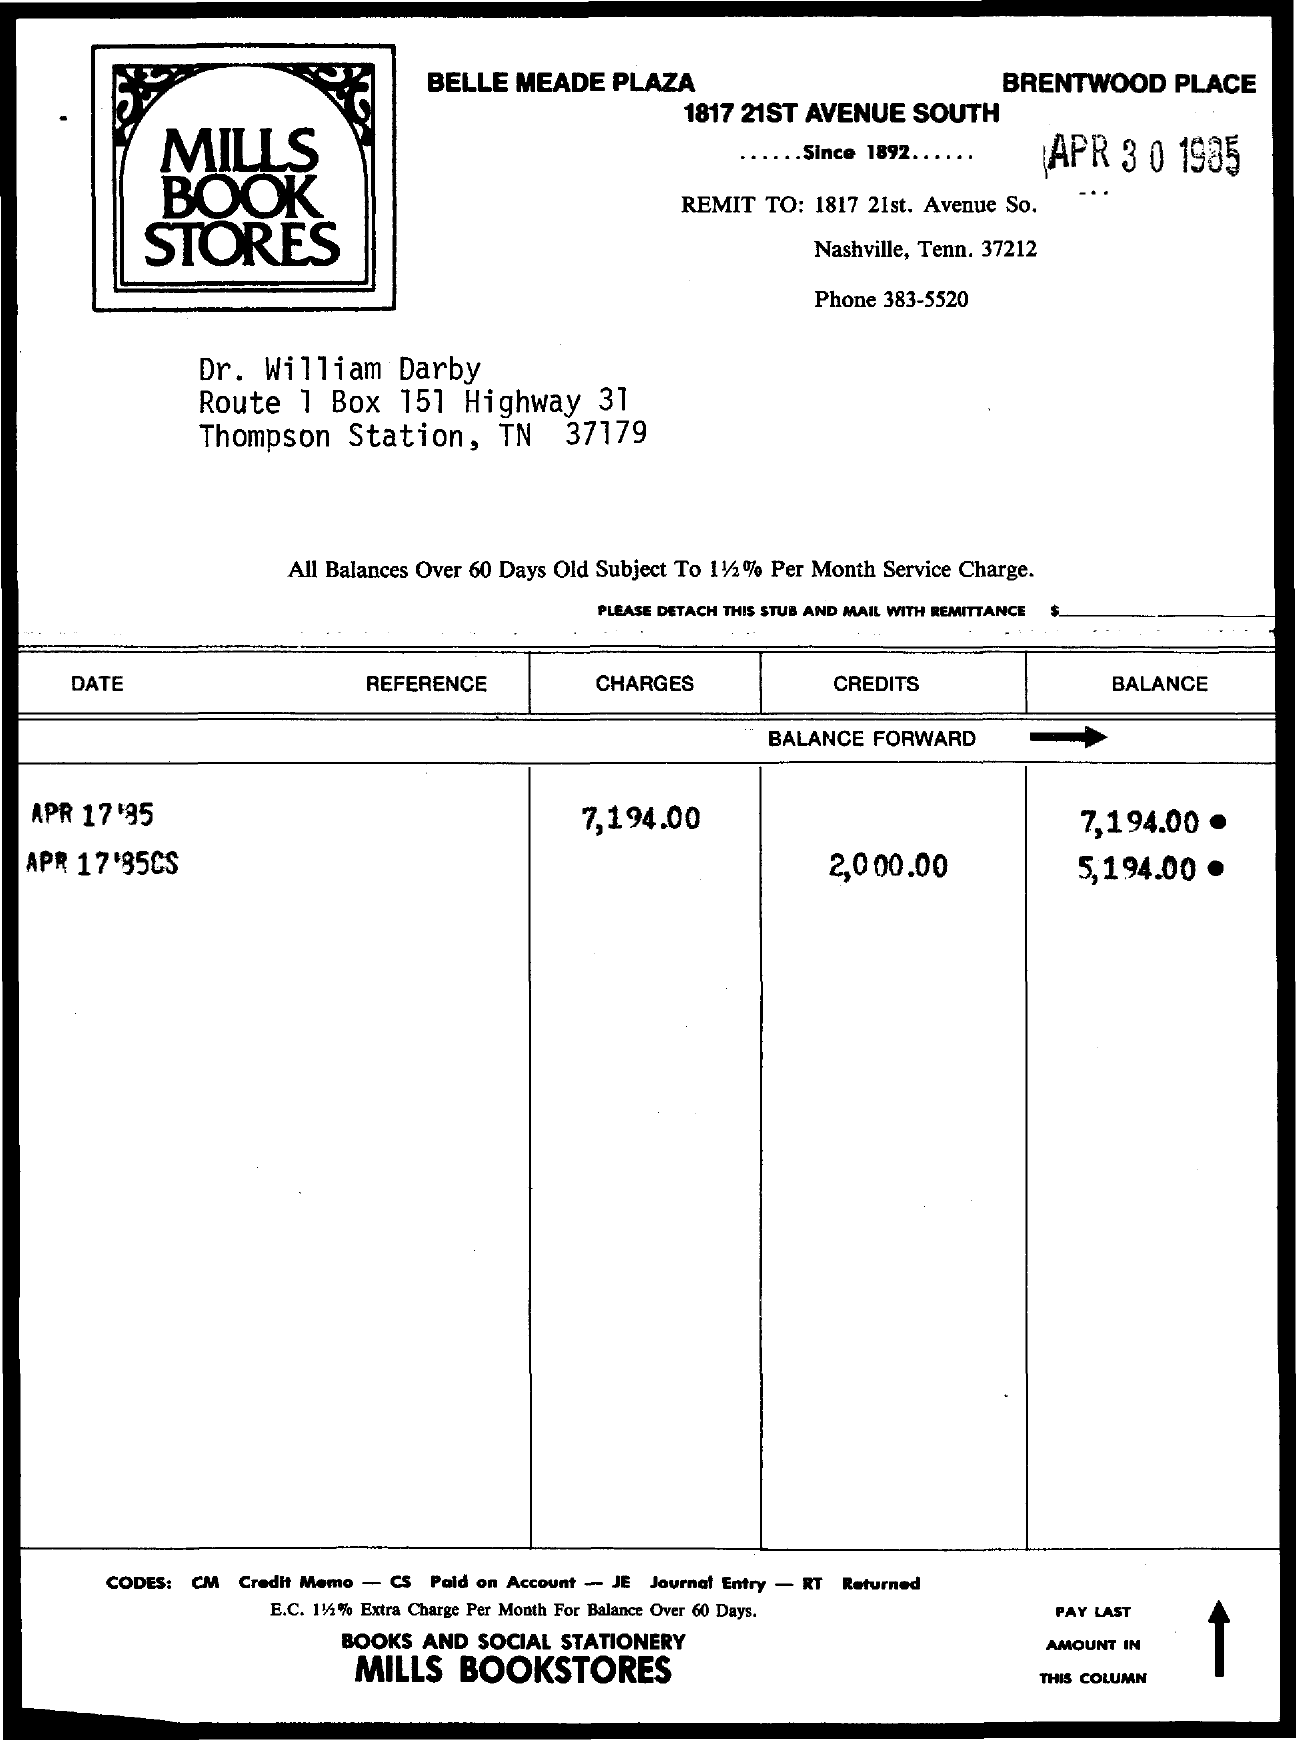Highlight a few significant elements in this photo. The phone number is 383-5520. The BoX number is 151. 